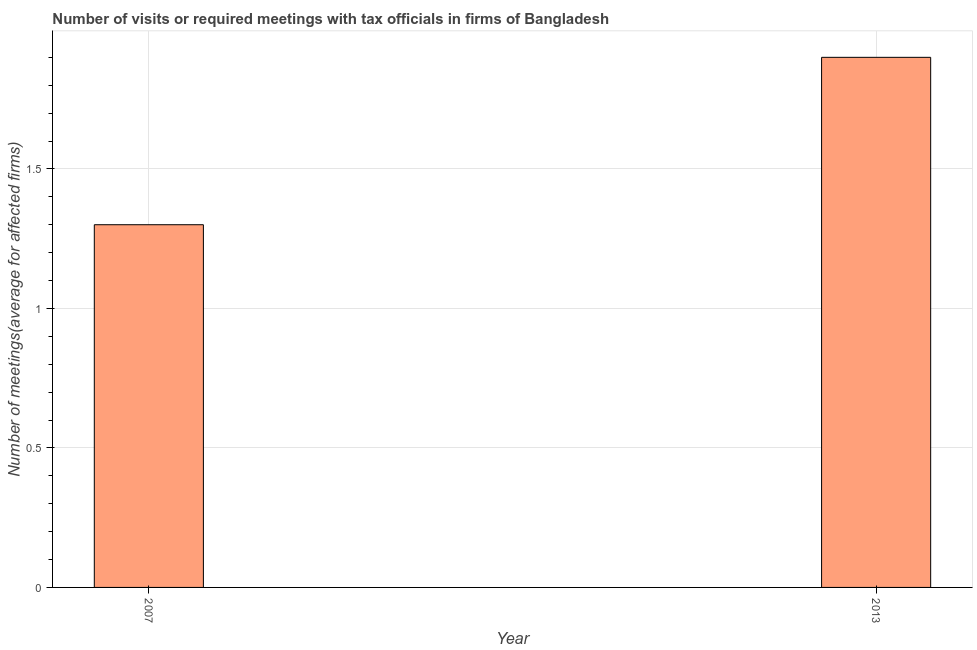Does the graph contain any zero values?
Offer a terse response. No. What is the title of the graph?
Make the answer very short. Number of visits or required meetings with tax officials in firms of Bangladesh. What is the label or title of the Y-axis?
Keep it short and to the point. Number of meetings(average for affected firms). In which year was the number of required meetings with tax officials maximum?
Offer a very short reply. 2013. In which year was the number of required meetings with tax officials minimum?
Your answer should be very brief. 2007. What is the difference between the number of required meetings with tax officials in 2007 and 2013?
Keep it short and to the point. -0.6. What is the average number of required meetings with tax officials per year?
Your answer should be compact. 1.6. In how many years, is the number of required meetings with tax officials greater than 1.2 ?
Provide a short and direct response. 2. Do a majority of the years between 2007 and 2013 (inclusive) have number of required meetings with tax officials greater than 0.1 ?
Provide a short and direct response. Yes. What is the ratio of the number of required meetings with tax officials in 2007 to that in 2013?
Your response must be concise. 0.68. In how many years, is the number of required meetings with tax officials greater than the average number of required meetings with tax officials taken over all years?
Make the answer very short. 1. How many bars are there?
Your response must be concise. 2. Are all the bars in the graph horizontal?
Give a very brief answer. No. What is the difference between the Number of meetings(average for affected firms) in 2007 and 2013?
Offer a very short reply. -0.6. What is the ratio of the Number of meetings(average for affected firms) in 2007 to that in 2013?
Your answer should be compact. 0.68. 